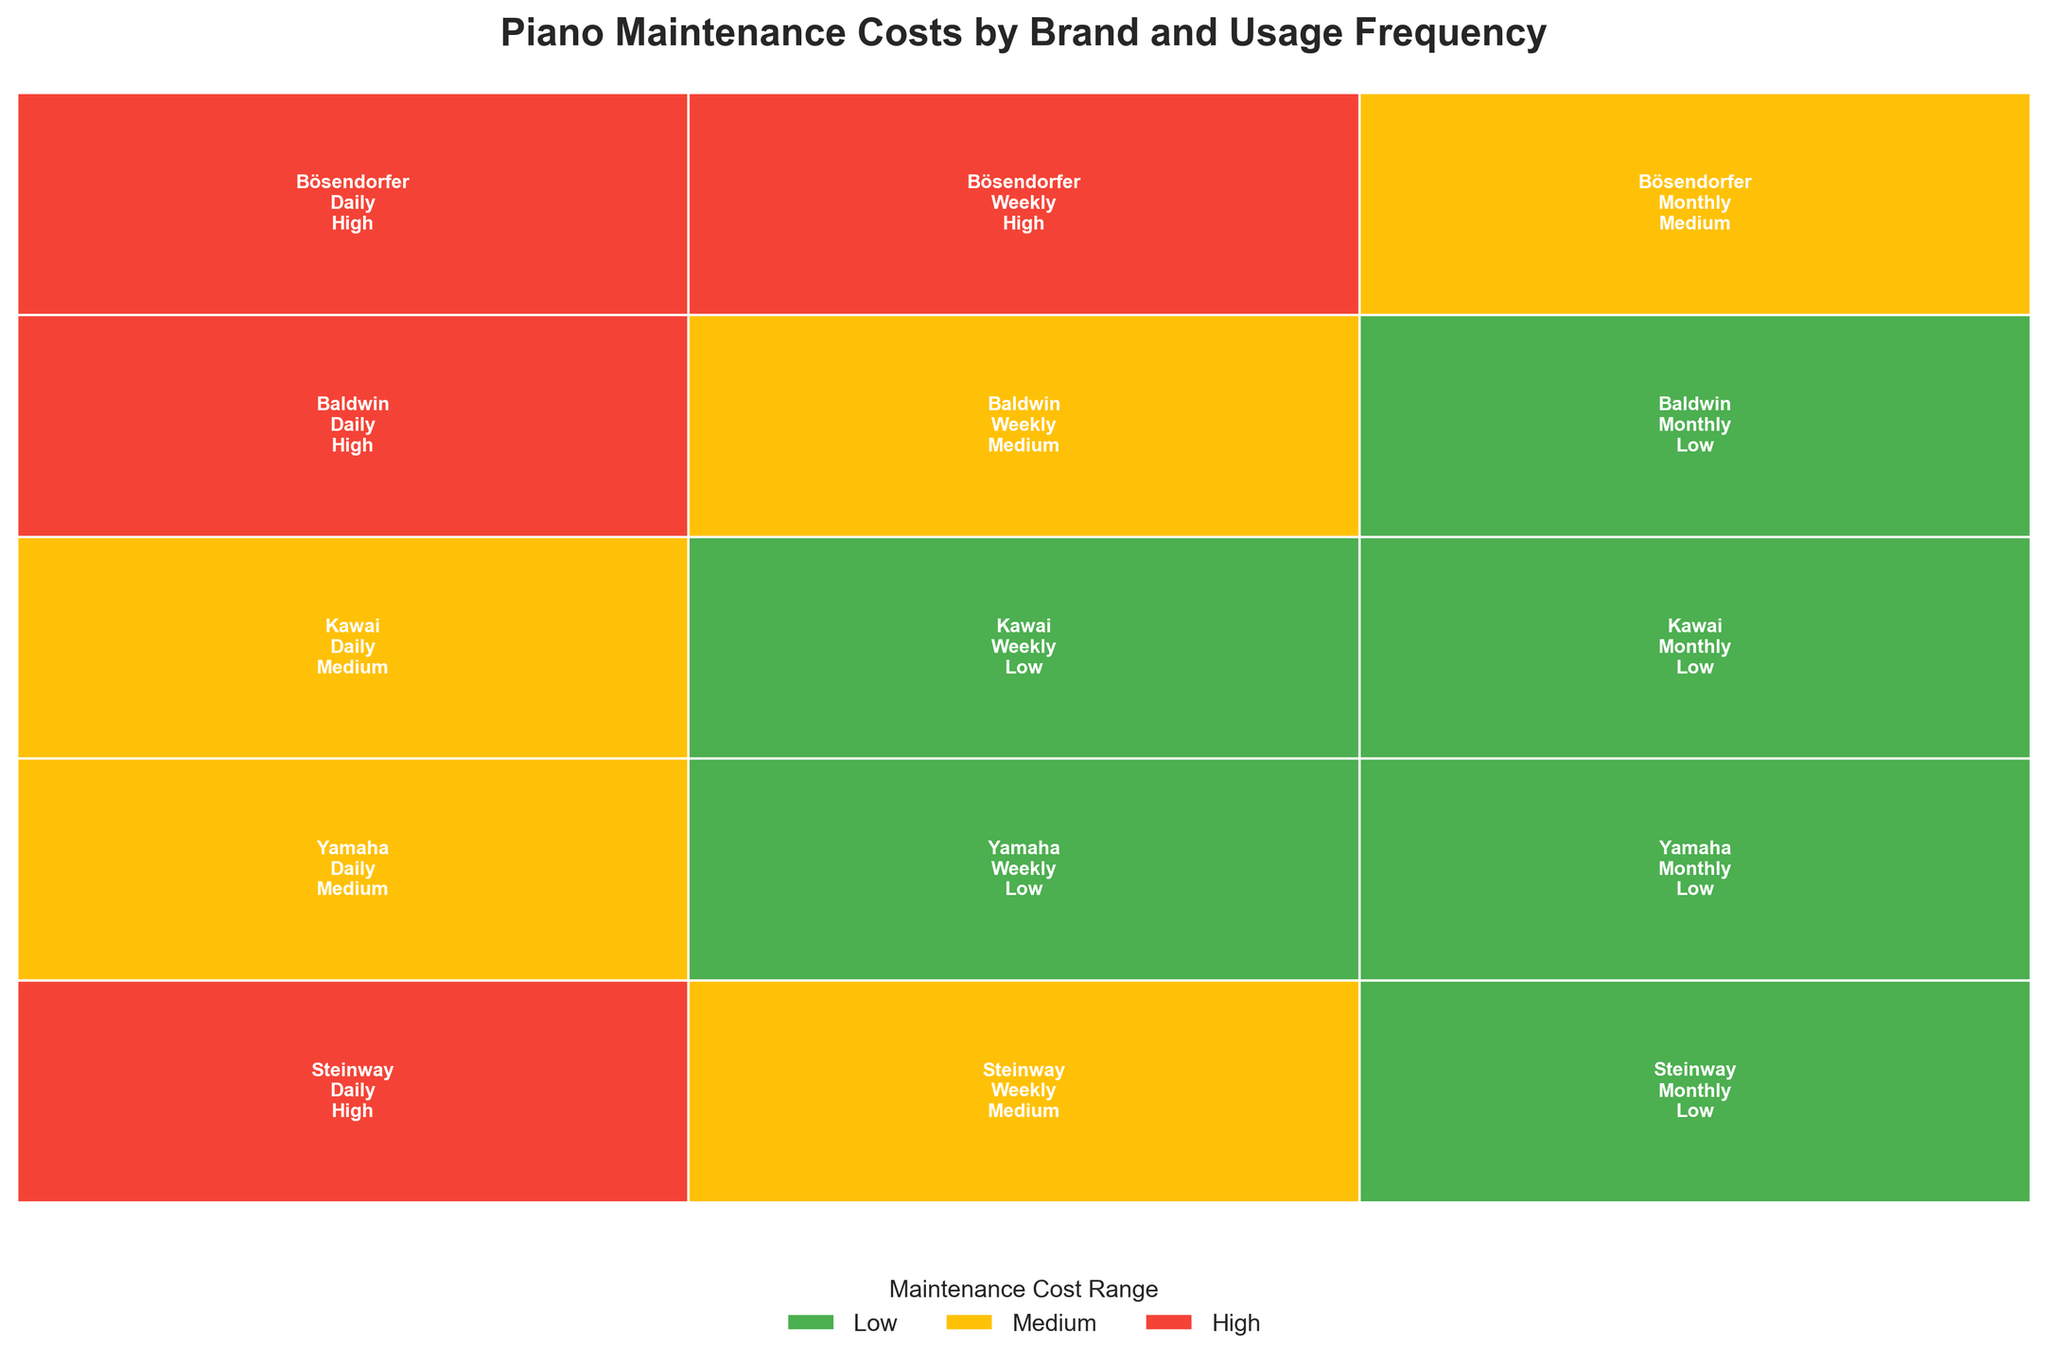Which brands have a 'High' maintenance cost range for pianos used 'Daily'? On the figure, identify rectangles with 'High' maintenance cost within the 'Daily' usage frequency section and read the corresponding brands within those rectangles.
Answer: Steinway, Baldwin, Bösendorfer What is the usage frequency distribution for Yamaha pianos? Locate the Yamaha section in the plot and observe the segments allocated for 'Daily', 'Weekly', and 'Monthly' usage.
Answer: Daily, Weekly, Monthly Which brand has the most diversified maintenance costs across different usage frequencies? Check for the brand with segments of multiple colors (Low, Medium, High). The brand with the most colors across usage frequencies is the answer.
Answer: Bösendorfer How does the maintenance cost range of Kawai pianos compare when used 'Daily' versus 'Monthly'? Locate the Kawai section. Compare the 'Daily' usage rectangle and the 'Monthly' usage rectangle to see their colors and interpret the corresponding maintenance costs.
Answer: 'Daily' is Medium, 'Monthly' is Low Which usage frequency has more brands with a 'Medium' maintenance cost range? Count the number of rectangles with 'Medium' maintenance cost for 'Daily', 'Weekly', and 'Monthly' usage frequencies.
Answer: Daily How many Steinway rectangles indicate a 'Low' maintenance cost? Look for the number of rectangles in the Steinway section that are colored according to the 'Low' maintenance cost.
Answer: 1 What is the overall trend of maintenance costs for pianos as the usage frequency decreases? Examine the pattern of colors across 'Daily', 'Weekly', and 'Monthly' and note general trends. Lower maintenance costs should appear more frequently in 'Monthly' sections.
Answer: Costs tend to decrease Which brand, other than Bösendorfer, has more than one usage frequency with a 'High' maintenance cost? Locate all brands with 'High' maintenance costs and check their frequency categories to see if more than one applies.
Answer: Baldwin In brands with 'High' maintenance costs for 'Weekly' usage frequency, which brand also has 'Low' maintenance costs for 'Monthly' usage? Look for brands with 'High' cost under 'Weekly' and then check their corresponding 'Monthly' sections for 'Low' costs.
Answer: Bösendorfer 